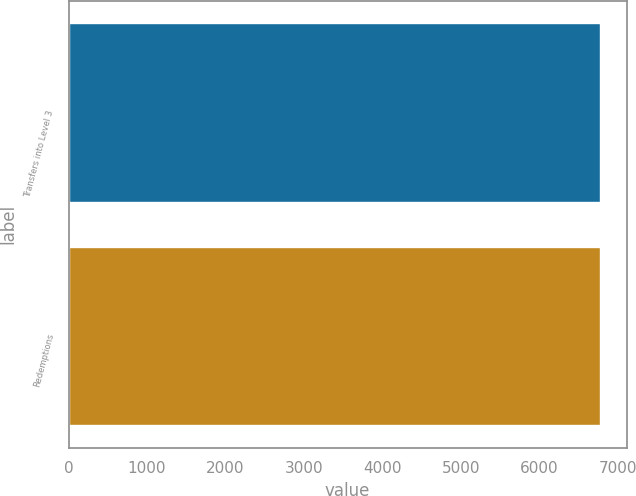<chart> <loc_0><loc_0><loc_500><loc_500><bar_chart><fcel>Transfers into Level 3<fcel>Redemptions<nl><fcel>6770<fcel>6770.1<nl></chart> 